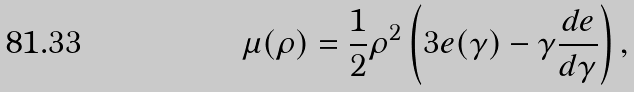Convert formula to latex. <formula><loc_0><loc_0><loc_500><loc_500>\mu ( \rho ) = \frac { 1 } { 2 } \rho ^ { 2 } \left ( 3 e ( \gamma ) - \gamma \frac { d e } { d \gamma } \right ) ,</formula> 